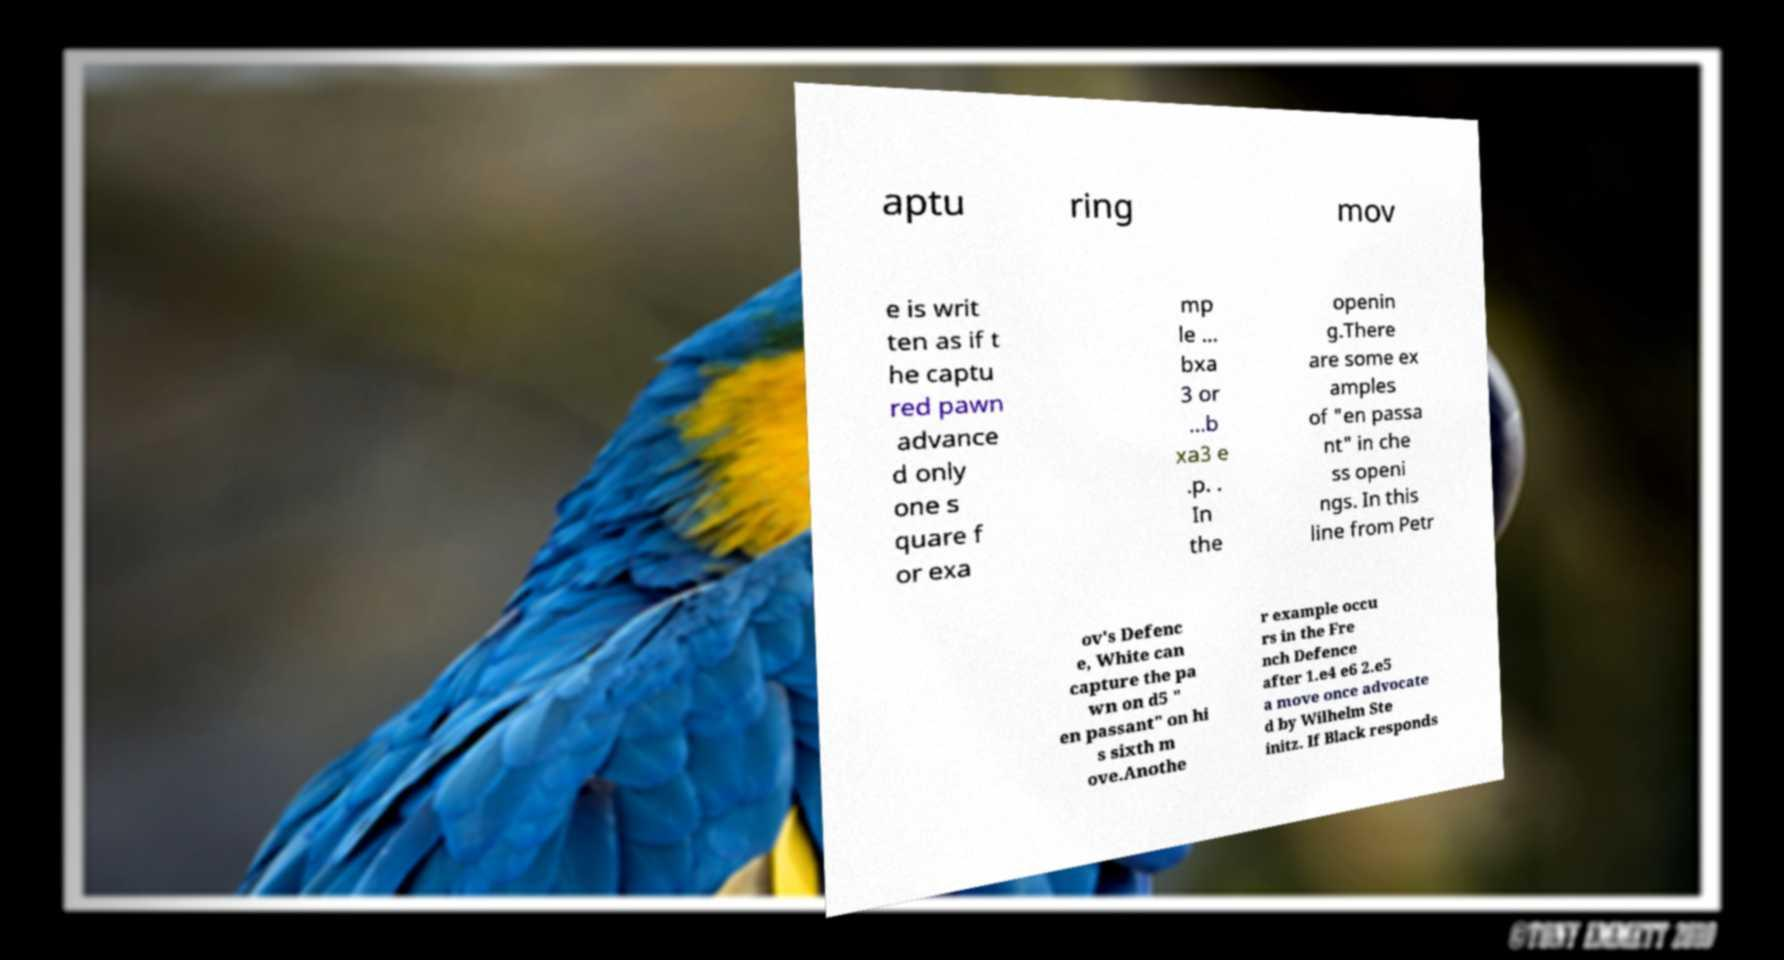Could you assist in decoding the text presented in this image and type it out clearly? aptu ring mov e is writ ten as if t he captu red pawn advance d only one s quare f or exa mp le ... bxa 3 or ...b xa3 e .p. . In the openin g.There are some ex amples of "en passa nt" in che ss openi ngs. In this line from Petr ov's Defenc e, White can capture the pa wn on d5 " en passant" on hi s sixth m ove.Anothe r example occu rs in the Fre nch Defence after 1.e4 e6 2.e5 a move once advocate d by Wilhelm Ste initz. If Black responds 